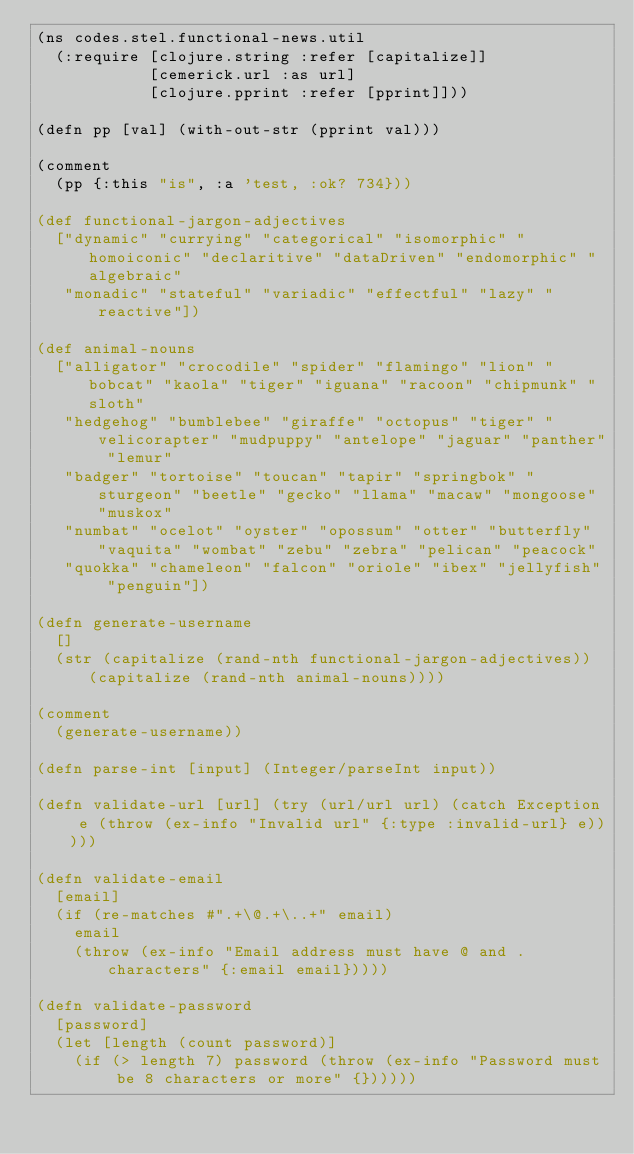Convert code to text. <code><loc_0><loc_0><loc_500><loc_500><_Clojure_>(ns codes.stel.functional-news.util
  (:require [clojure.string :refer [capitalize]]
            [cemerick.url :as url]
            [clojure.pprint :refer [pprint]]))

(defn pp [val] (with-out-str (pprint val)))

(comment
  (pp {:this "is", :a 'test, :ok? 734}))

(def functional-jargon-adjectives
  ["dynamic" "currying" "categorical" "isomorphic" "homoiconic" "declaritive" "dataDriven" "endomorphic" "algebraic"
   "monadic" "stateful" "variadic" "effectful" "lazy" "reactive"])

(def animal-nouns
  ["alligator" "crocodile" "spider" "flamingo" "lion" "bobcat" "kaola" "tiger" "iguana" "racoon" "chipmunk" "sloth"
   "hedgehog" "bumblebee" "giraffe" "octopus" "tiger" "velicorapter" "mudpuppy" "antelope" "jaguar" "panther" "lemur"
   "badger" "tortoise" "toucan" "tapir" "springbok" "sturgeon" "beetle" "gecko" "llama" "macaw" "mongoose" "muskox"
   "numbat" "ocelot" "oyster" "opossum" "otter" "butterfly" "vaquita" "wombat" "zebu" "zebra" "pelican" "peacock"
   "quokka" "chameleon" "falcon" "oriole" "ibex" "jellyfish" "penguin"])

(defn generate-username
  []
  (str (capitalize (rand-nth functional-jargon-adjectives)) (capitalize (rand-nth animal-nouns))))

(comment
  (generate-username))

(defn parse-int [input] (Integer/parseInt input))

(defn validate-url [url] (try (url/url url) (catch Exception e (throw (ex-info "Invalid url" {:type :invalid-url} e)))))

(defn validate-email
  [email]
  (if (re-matches #".+\@.+\..+" email)
    email
    (throw (ex-info "Email address must have @ and . characters" {:email email}))))

(defn validate-password
  [password]
  (let [length (count password)]
    (if (> length 7) password (throw (ex-info "Password must be 8 characters or more" {})))))
</code> 